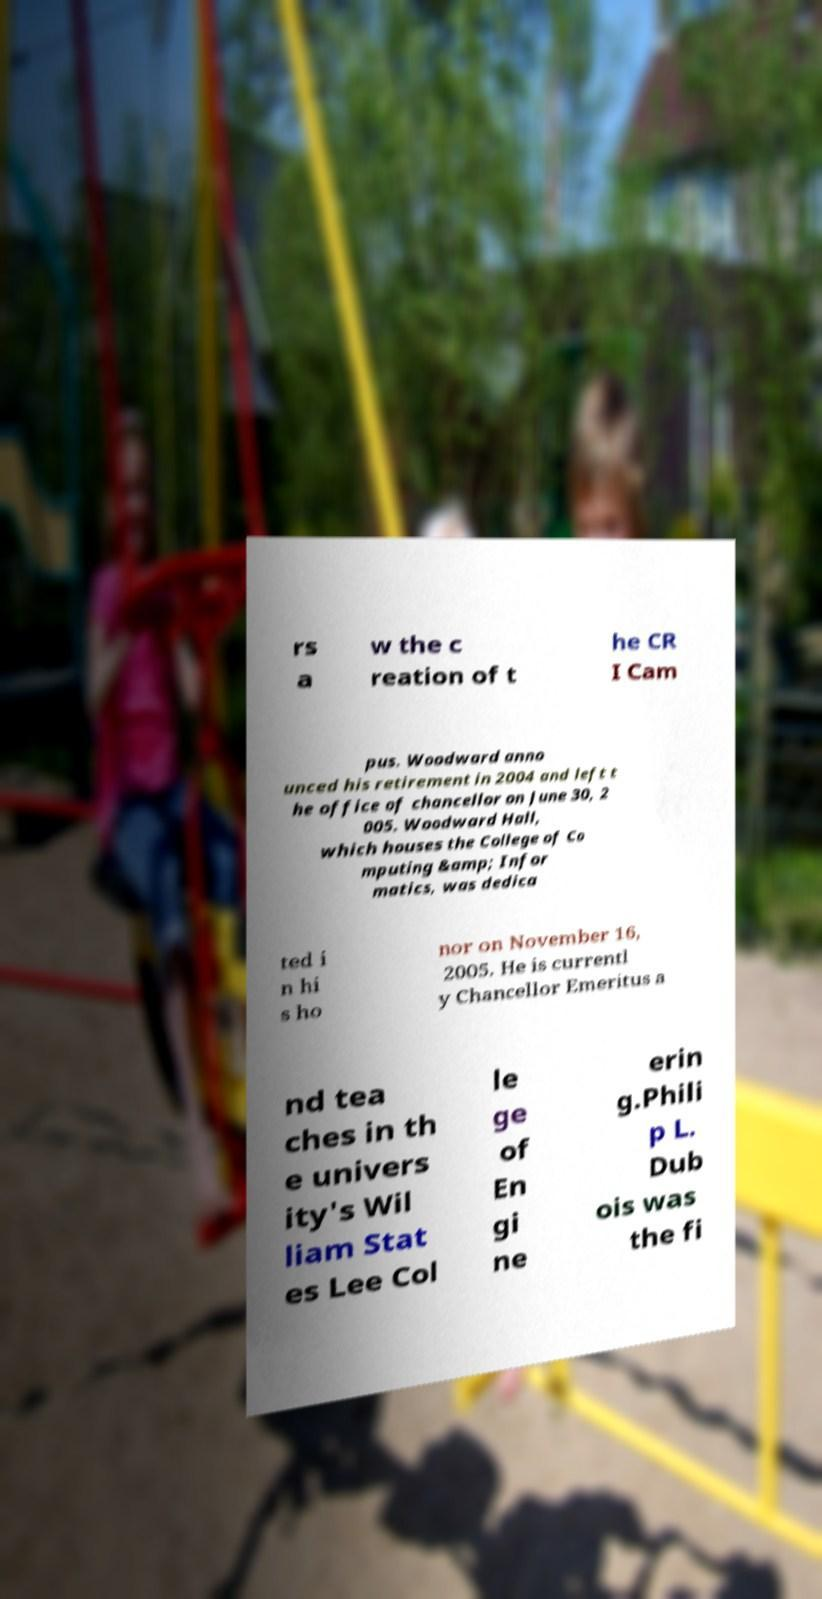For documentation purposes, I need the text within this image transcribed. Could you provide that? rs a w the c reation of t he CR I Cam pus. Woodward anno unced his retirement in 2004 and left t he office of chancellor on June 30, 2 005. Woodward Hall, which houses the College of Co mputing &amp; Infor matics, was dedica ted i n hi s ho nor on November 16, 2005. He is currentl y Chancellor Emeritus a nd tea ches in th e univers ity's Wil liam Stat es Lee Col le ge of En gi ne erin g.Phili p L. Dub ois was the fi 